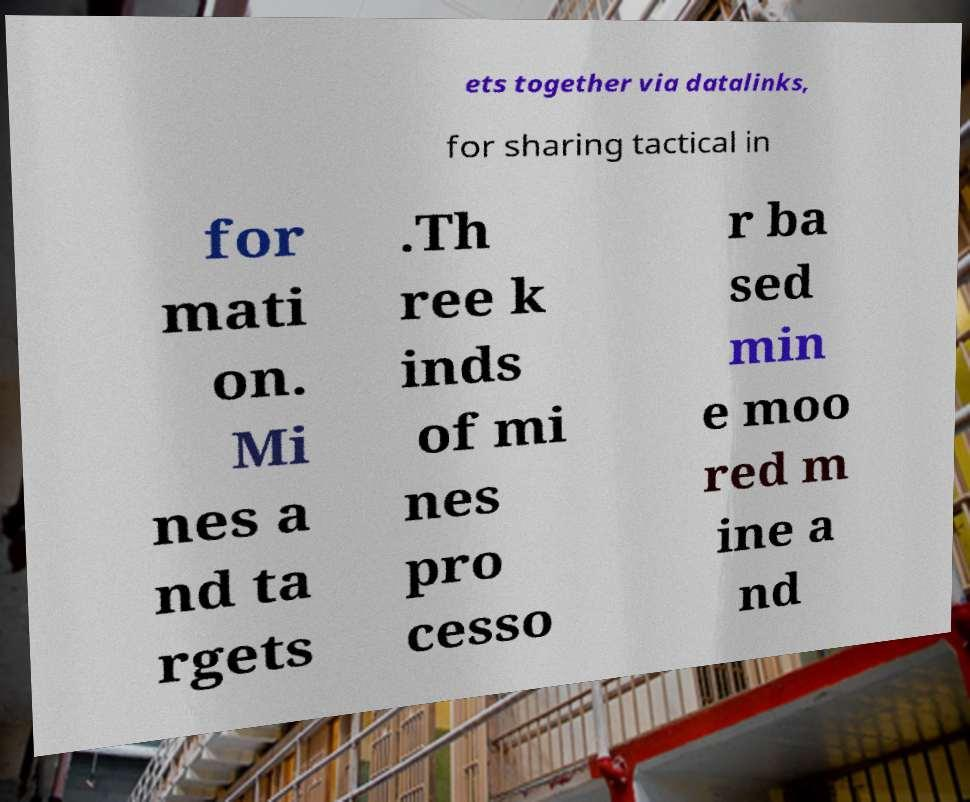Can you read and provide the text displayed in the image?This photo seems to have some interesting text. Can you extract and type it out for me? ets together via datalinks, for sharing tactical in for mati on. Mi nes a nd ta rgets .Th ree k inds of mi nes pro cesso r ba sed min e moo red m ine a nd 